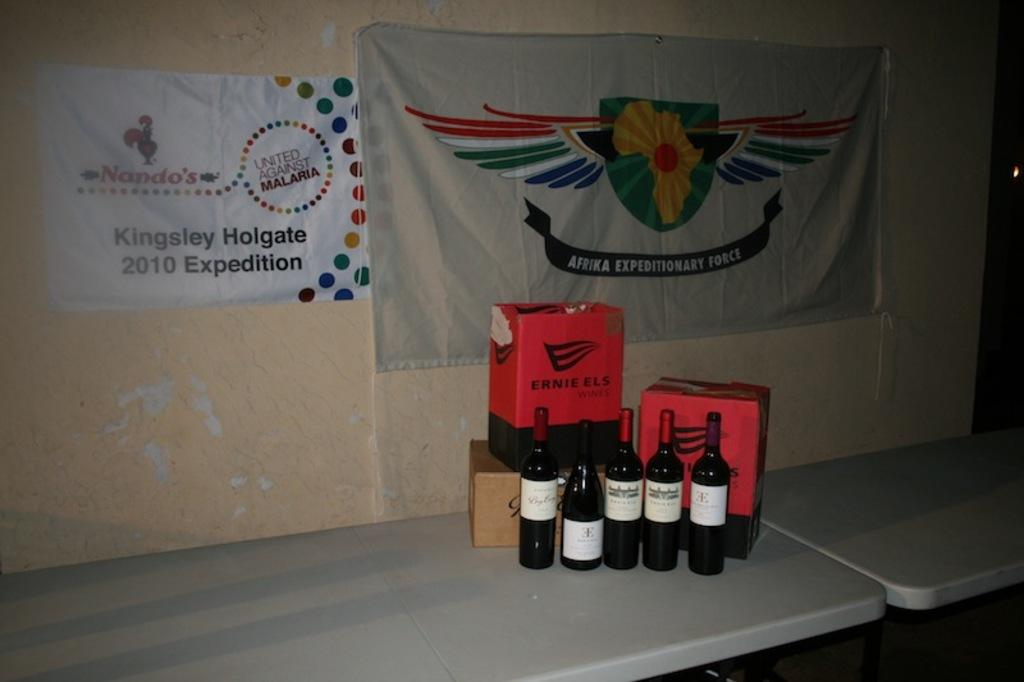What type of furniture can be seen at the bottom of the image? There are tables at the bottom of the image. What items are placed on the tables? Bottles and boxes are present on the tables. What can be seen in the background of the image? There are banners and a wall in the background of the image. What type of disgust can be seen on the quartz in the image? There is no quartz or disgust present in the image. What is the plot of the story unfolding in the image? The image does not depict a story or plot; it shows tables with bottles and boxes, along with banners and a wall in the background. 